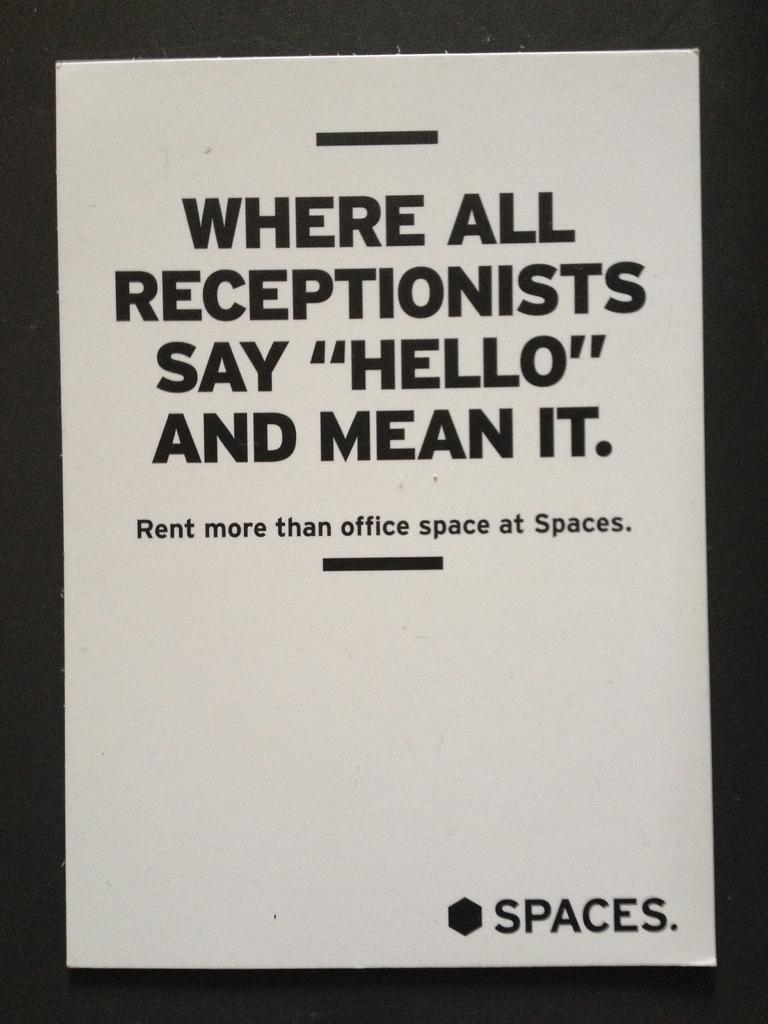<image>
Offer a succinct explanation of the picture presented. An ad for spaces is framed in a black frame. 